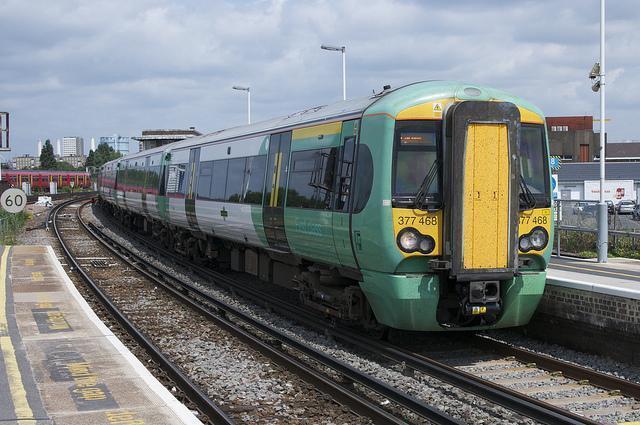How many railways are there?
Give a very brief answer. 2. How many tracks can you see here?
Give a very brief answer. 2. How many trains are visible?
Give a very brief answer. 1. 